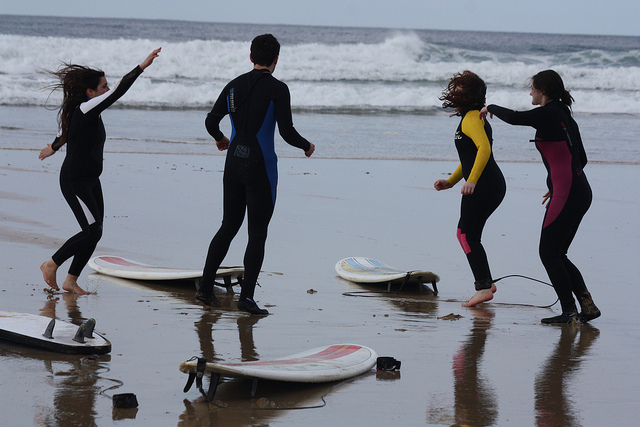What's the weather like at the beach? The sky is overcast, and the sea appears slightly rough, indicating it might be a cool and windy day at the beach, suitable for wetsuits the individuals are wearing. 